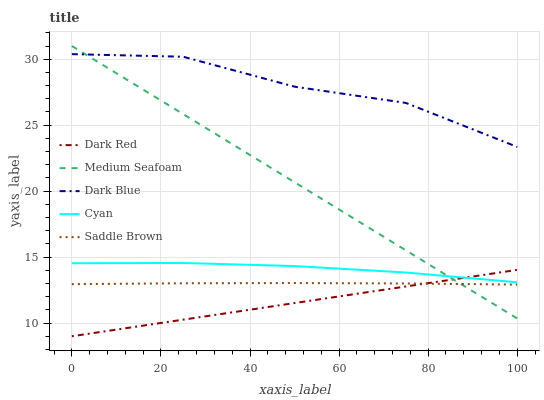Does Dark Red have the minimum area under the curve?
Answer yes or no. Yes. Does Dark Blue have the maximum area under the curve?
Answer yes or no. Yes. Does Cyan have the minimum area under the curve?
Answer yes or no. No. Does Cyan have the maximum area under the curve?
Answer yes or no. No. Is Medium Seafoam the smoothest?
Answer yes or no. Yes. Is Dark Blue the roughest?
Answer yes or no. Yes. Is Dark Red the smoothest?
Answer yes or no. No. Is Dark Red the roughest?
Answer yes or no. No. Does Cyan have the lowest value?
Answer yes or no. No. Does Dark Red have the highest value?
Answer yes or no. No. Is Saddle Brown less than Cyan?
Answer yes or no. Yes. Is Dark Blue greater than Dark Red?
Answer yes or no. Yes. Does Saddle Brown intersect Cyan?
Answer yes or no. No. 